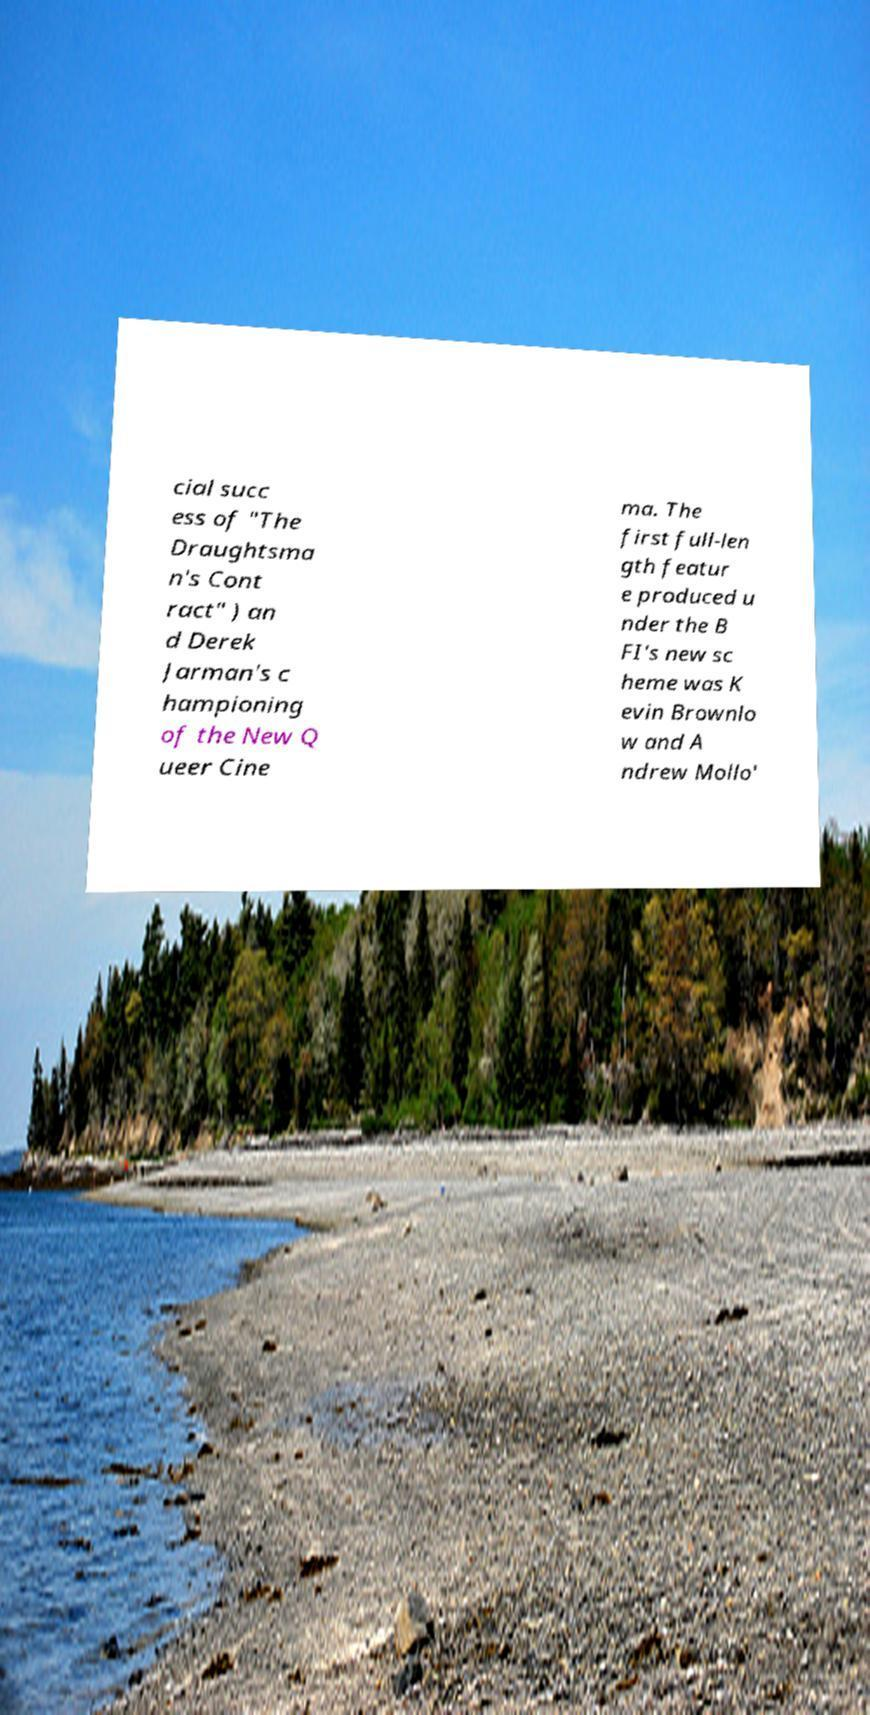Please read and relay the text visible in this image. What does it say? cial succ ess of "The Draughtsma n's Cont ract" ) an d Derek Jarman's c hampioning of the New Q ueer Cine ma. The first full-len gth featur e produced u nder the B FI's new sc heme was K evin Brownlo w and A ndrew Mollo' 